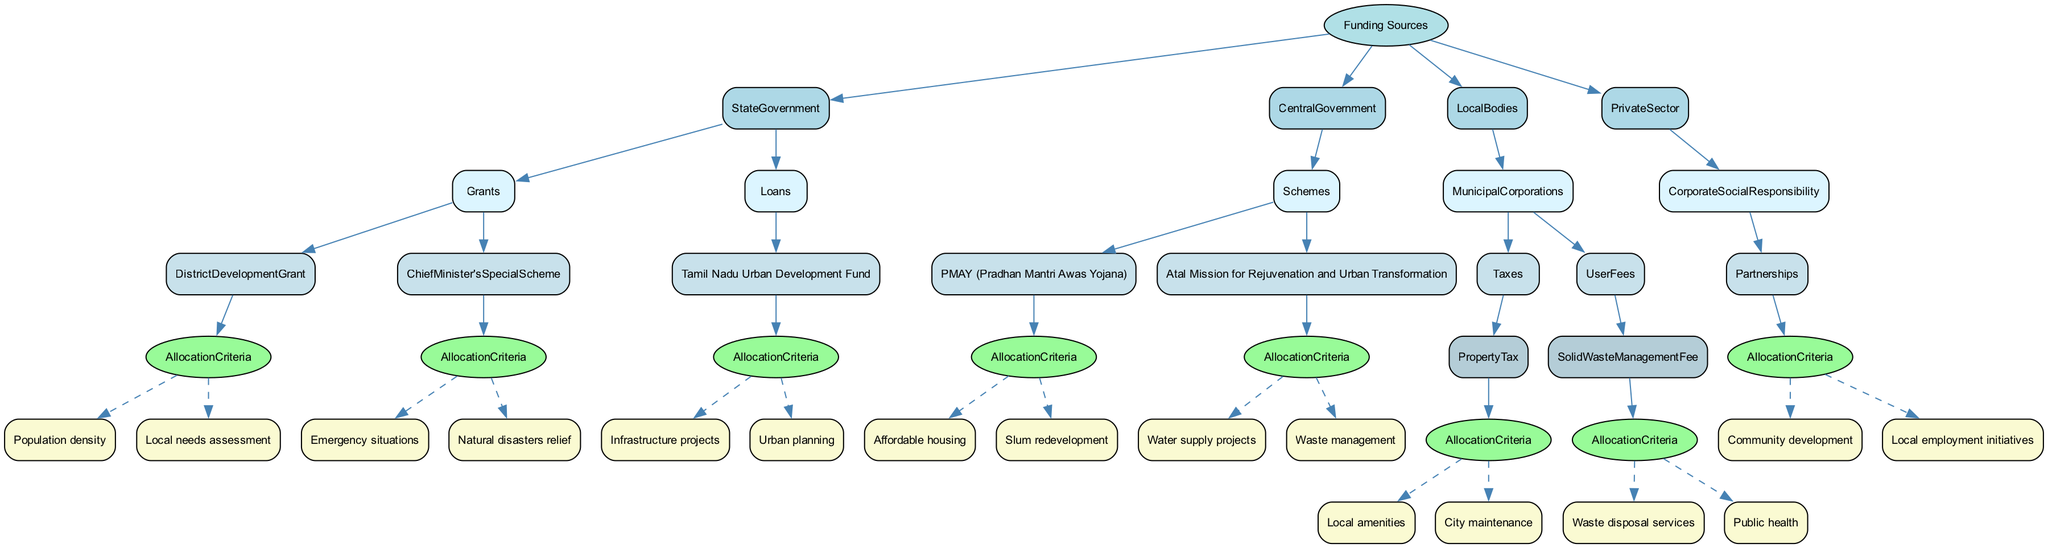What are the main funding sources identified in the diagram? The diagram indicates four main funding sources: State Government, Central Government, Local Bodies, and Private Sector. Each of these is a distinct category governing different methods of funding allocation.
Answer: State Government, Central Government, Local Bodies, Private Sector How many allocation criteria are associated with District Development Grant? The District Development Grant has two allocation criteria listed: Population density and Local needs assessment. This can be counted directly from the diagram under the respective node.
Answer: 2 Which funding source is associated with the scheme for affordable housing? The scheme for affordable housing is linked to the PMAY (Pradhan Mantri Awas Yojana), which falls under the Central Government funding source in the diagram. It is explicitly indicated in the hierarchical structure of the funding sources.
Answer: PMAY (Pradhan Mantri Awas Yojana) What criteria must be met for the Chief Minister's Special Scheme funding? The Chief Minister's Special Scheme funding criteria are Emergency situations and Natural disasters relief. This information is found directly beneath the respective funding source in the diagram.
Answer: Emergency situations, Natural disasters relief Which funding source provides loans specifically for urban planning? The Tamil Nadu Urban Development Fund provides loans for urban planning, as depicted under the State Government category in the loan section of the diagram.
Answer: Tamil Nadu Urban Development Fund How many funding categories are listed under Local Bodies? There are two funding categories under Local Bodies: Municipal Corporations and User Fees. This is determined by counting the top-level nodes connected to Local Bodies.
Answer: 2 Which allocation criteria are linked to the Solid Waste Management Fee? The Solid Waste Management Fee has two linked allocation criteria: Waste disposal services and Public health. This is found under the User Fees node in the diagram, indicating the specific criteria for this funding source.
Answer: Waste disposal services, Public health Which funding source focuses on community development? The Corporate Social Responsibility funding source focuses on community development through partnerships, as seen in the Private Sector category of the diagram.
Answer: Corporate Social Responsibility 